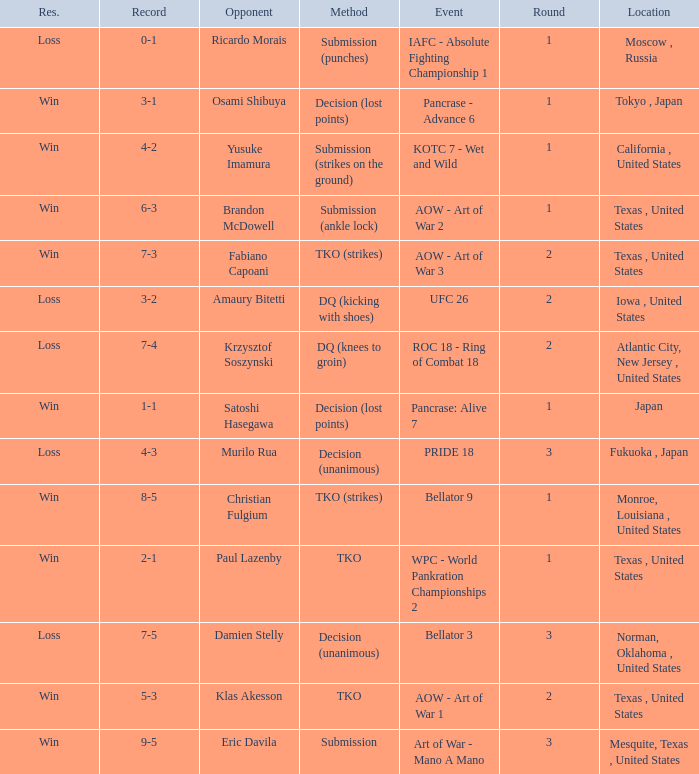What is the average round against opponent Klas Akesson? 2.0. 